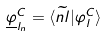<formula> <loc_0><loc_0><loc_500><loc_500>\underline { \varphi } _ { l _ { n } } ^ { C } = \langle \widetilde { n l } | \varphi _ { l } ^ { C } \rangle</formula> 